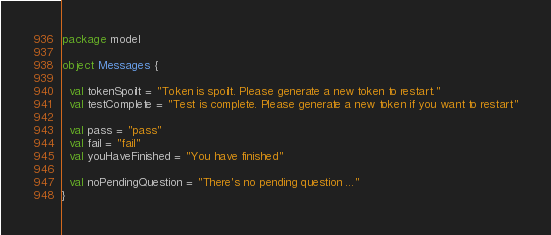Convert code to text. <code><loc_0><loc_0><loc_500><loc_500><_Scala_>package model

object Messages {

  val tokenSpoilt = "Token is spoilt. Please generate a new token to restart."
  val testComplete = "Test is complete. Please generate a new token if you want to restart"

  val pass = "pass"
  val fail = "fail"
  val youHaveFinished = "You have finished"

  val noPendingQuestion = "There's no pending question ..."
}
</code> 